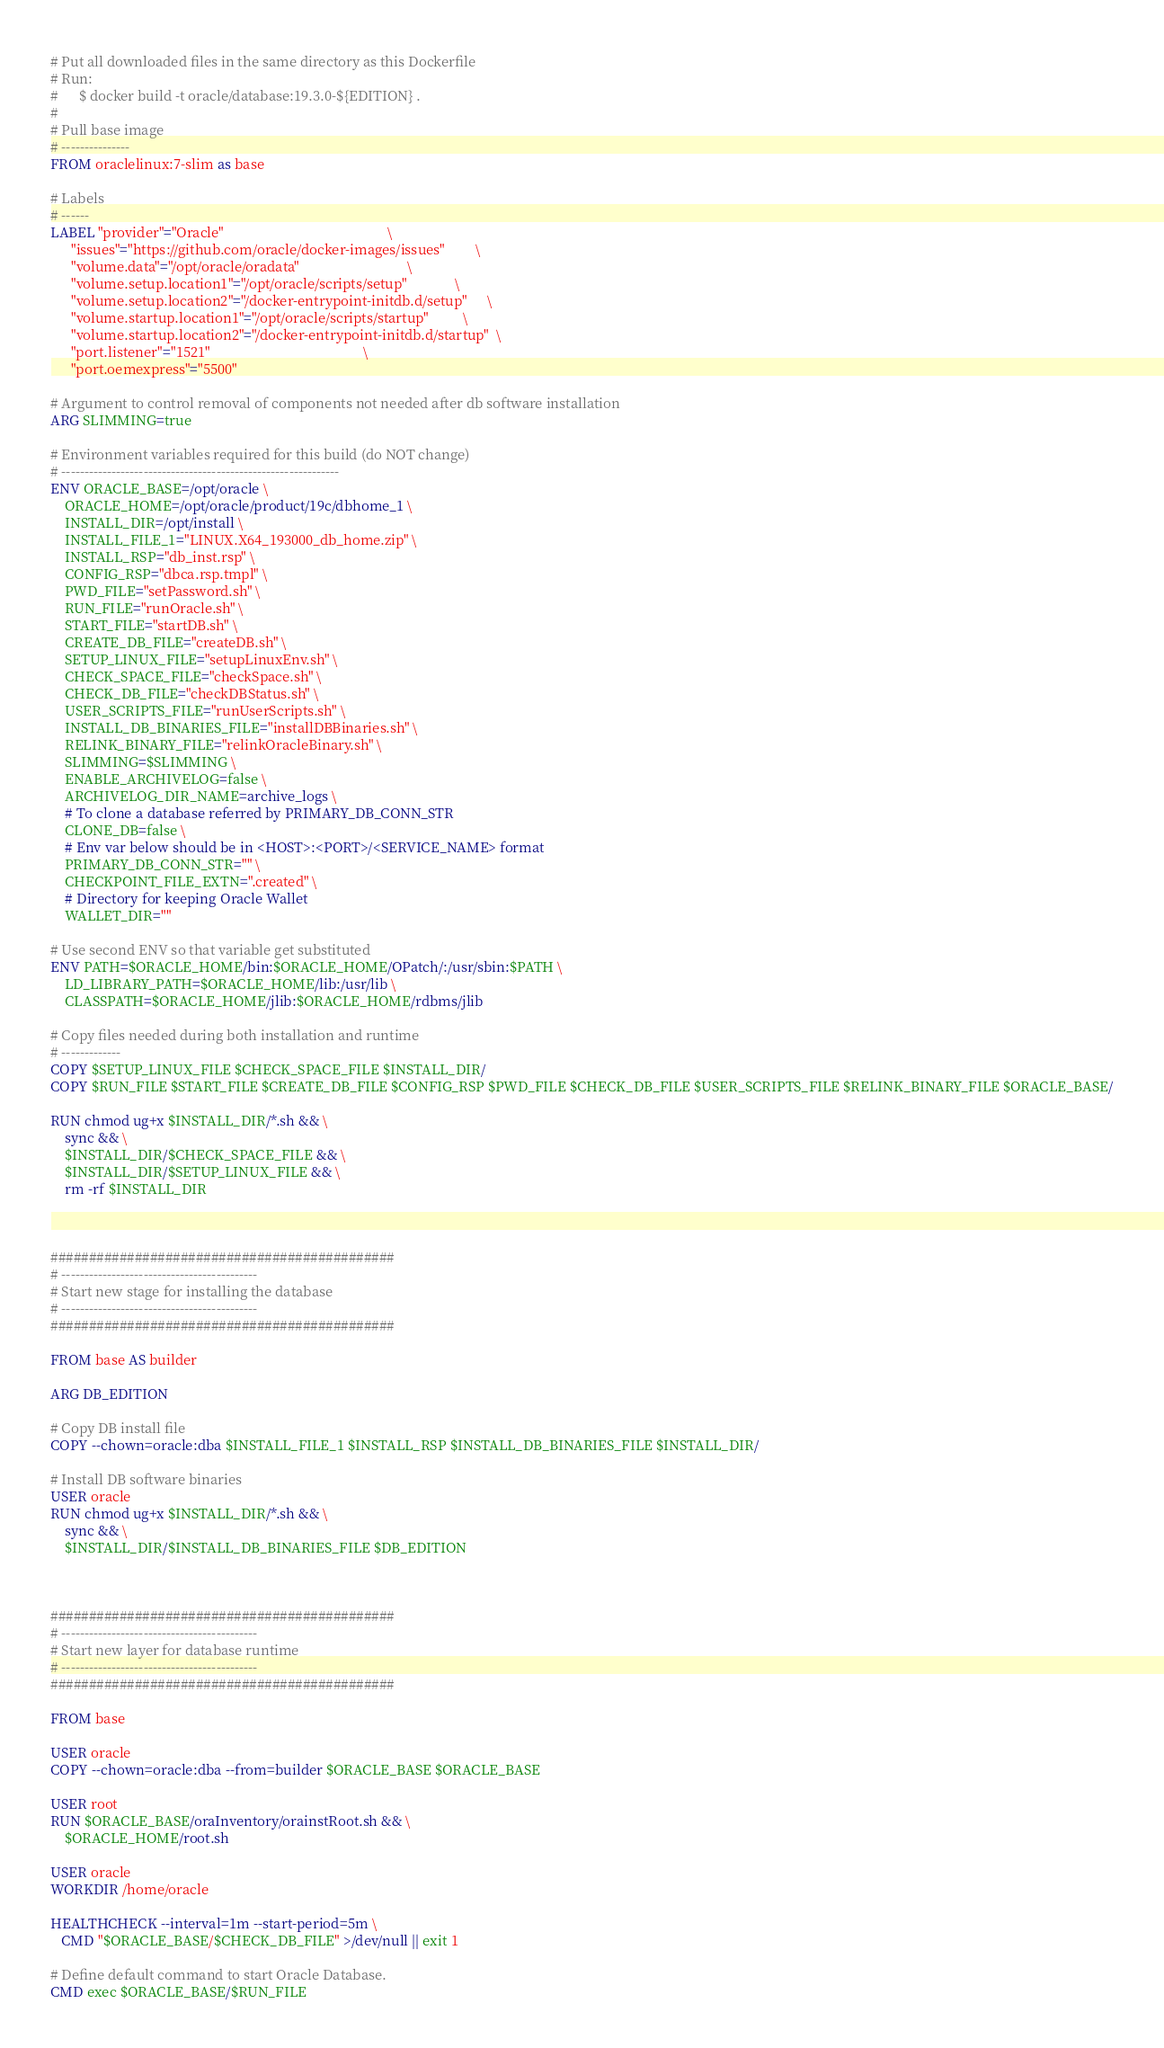Convert code to text. <code><loc_0><loc_0><loc_500><loc_500><_Dockerfile_># Put all downloaded files in the same directory as this Dockerfile
# Run: 
#      $ docker build -t oracle/database:19.3.0-${EDITION} . 
#
# Pull base image
# ---------------
FROM oraclelinux:7-slim as base

# Labels
# ------
LABEL "provider"="Oracle"                                               \
      "issues"="https://github.com/oracle/docker-images/issues"         \
      "volume.data"="/opt/oracle/oradata"                               \
      "volume.setup.location1"="/opt/oracle/scripts/setup"              \
      "volume.setup.location2"="/docker-entrypoint-initdb.d/setup"      \
      "volume.startup.location1"="/opt/oracle/scripts/startup"          \
      "volume.startup.location2"="/docker-entrypoint-initdb.d/startup"  \
      "port.listener"="1521"                                            \
      "port.oemexpress"="5500"

# Argument to control removal of components not needed after db software installation
ARG SLIMMING=true

# Environment variables required for this build (do NOT change)
# -------------------------------------------------------------
ENV ORACLE_BASE=/opt/oracle \
    ORACLE_HOME=/opt/oracle/product/19c/dbhome_1 \
    INSTALL_DIR=/opt/install \
    INSTALL_FILE_1="LINUX.X64_193000_db_home.zip" \
    INSTALL_RSP="db_inst.rsp" \
    CONFIG_RSP="dbca.rsp.tmpl" \
    PWD_FILE="setPassword.sh" \
    RUN_FILE="runOracle.sh" \
    START_FILE="startDB.sh" \
    CREATE_DB_FILE="createDB.sh" \
    SETUP_LINUX_FILE="setupLinuxEnv.sh" \
    CHECK_SPACE_FILE="checkSpace.sh" \
    CHECK_DB_FILE="checkDBStatus.sh" \
    USER_SCRIPTS_FILE="runUserScripts.sh" \
    INSTALL_DB_BINARIES_FILE="installDBBinaries.sh" \
    RELINK_BINARY_FILE="relinkOracleBinary.sh" \
    SLIMMING=$SLIMMING \
    ENABLE_ARCHIVELOG=false \
    ARCHIVELOG_DIR_NAME=archive_logs \
    # To clone a database referred by PRIMARY_DB_CONN_STR
    CLONE_DB=false \
    # Env var below should be in <HOST>:<PORT>/<SERVICE_NAME> format
    PRIMARY_DB_CONN_STR="" \
    CHECKPOINT_FILE_EXTN=".created" \
    # Directory for keeping Oracle Wallet
    WALLET_DIR=""

# Use second ENV so that variable get substituted
ENV PATH=$ORACLE_HOME/bin:$ORACLE_HOME/OPatch/:/usr/sbin:$PATH \
    LD_LIBRARY_PATH=$ORACLE_HOME/lib:/usr/lib \
    CLASSPATH=$ORACLE_HOME/jlib:$ORACLE_HOME/rdbms/jlib

# Copy files needed during both installation and runtime
# -------------
COPY $SETUP_LINUX_FILE $CHECK_SPACE_FILE $INSTALL_DIR/
COPY $RUN_FILE $START_FILE $CREATE_DB_FILE $CONFIG_RSP $PWD_FILE $CHECK_DB_FILE $USER_SCRIPTS_FILE $RELINK_BINARY_FILE $ORACLE_BASE/

RUN chmod ug+x $INSTALL_DIR/*.sh && \
    sync && \
    $INSTALL_DIR/$CHECK_SPACE_FILE && \
    $INSTALL_DIR/$SETUP_LINUX_FILE && \
    rm -rf $INSTALL_DIR



#############################################
# -------------------------------------------
# Start new stage for installing the database
# -------------------------------------------
#############################################

FROM base AS builder

ARG DB_EDITION

# Copy DB install file
COPY --chown=oracle:dba $INSTALL_FILE_1 $INSTALL_RSP $INSTALL_DB_BINARIES_FILE $INSTALL_DIR/

# Install DB software binaries
USER oracle
RUN chmod ug+x $INSTALL_DIR/*.sh && \
    sync && \
    $INSTALL_DIR/$INSTALL_DB_BINARIES_FILE $DB_EDITION



#############################################
# -------------------------------------------
# Start new layer for database runtime
# -------------------------------------------
#############################################

FROM base

USER oracle
COPY --chown=oracle:dba --from=builder $ORACLE_BASE $ORACLE_BASE

USER root
RUN $ORACLE_BASE/oraInventory/orainstRoot.sh && \
    $ORACLE_HOME/root.sh

USER oracle
WORKDIR /home/oracle

HEALTHCHECK --interval=1m --start-period=5m \
   CMD "$ORACLE_BASE/$CHECK_DB_FILE" >/dev/null || exit 1

# Define default command to start Oracle Database. 
CMD exec $ORACLE_BASE/$RUN_FILE
</code> 